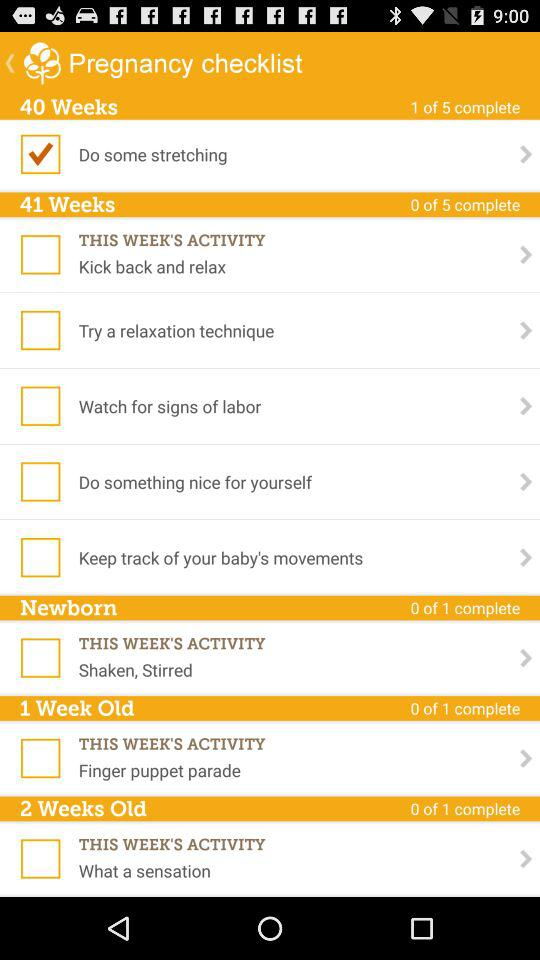Which option was checked? The checked option was "Do some stretching". 